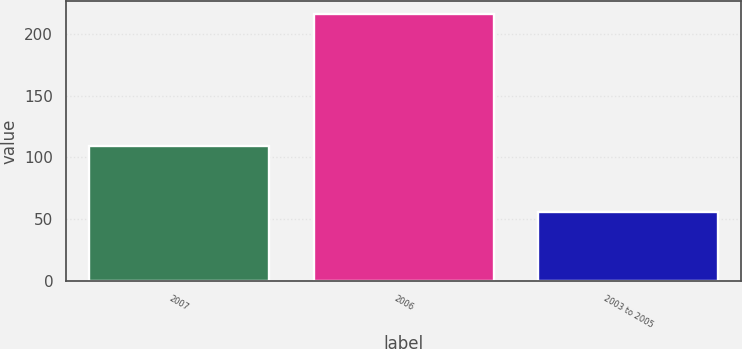Convert chart. <chart><loc_0><loc_0><loc_500><loc_500><bar_chart><fcel>2007<fcel>2006<fcel>2003 to 2005<nl><fcel>109<fcel>216<fcel>56<nl></chart> 